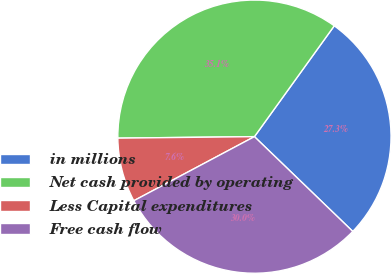Convert chart. <chart><loc_0><loc_0><loc_500><loc_500><pie_chart><fcel>in millions<fcel>Net cash provided by operating<fcel>Less Capital expenditures<fcel>Free cash flow<nl><fcel>27.27%<fcel>35.11%<fcel>7.6%<fcel>30.02%<nl></chart> 